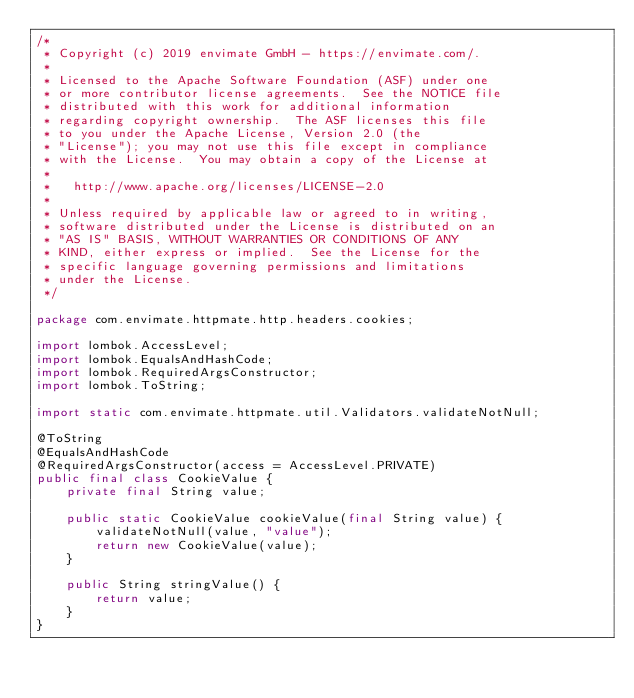Convert code to text. <code><loc_0><loc_0><loc_500><loc_500><_Java_>/*
 * Copyright (c) 2019 envimate GmbH - https://envimate.com/.
 *
 * Licensed to the Apache Software Foundation (ASF) under one
 * or more contributor license agreements.  See the NOTICE file
 * distributed with this work for additional information
 * regarding copyright ownership.  The ASF licenses this file
 * to you under the Apache License, Version 2.0 (the
 * "License"); you may not use this file except in compliance
 * with the License.  You may obtain a copy of the License at
 *
 *   http://www.apache.org/licenses/LICENSE-2.0
 *
 * Unless required by applicable law or agreed to in writing,
 * software distributed under the License is distributed on an
 * "AS IS" BASIS, WITHOUT WARRANTIES OR CONDITIONS OF ANY
 * KIND, either express or implied.  See the License for the
 * specific language governing permissions and limitations
 * under the License.
 */

package com.envimate.httpmate.http.headers.cookies;

import lombok.AccessLevel;
import lombok.EqualsAndHashCode;
import lombok.RequiredArgsConstructor;
import lombok.ToString;

import static com.envimate.httpmate.util.Validators.validateNotNull;

@ToString
@EqualsAndHashCode
@RequiredArgsConstructor(access = AccessLevel.PRIVATE)
public final class CookieValue {
    private final String value;

    public static CookieValue cookieValue(final String value) {
        validateNotNull(value, "value");
        return new CookieValue(value);
    }

    public String stringValue() {
        return value;
    }
}
</code> 